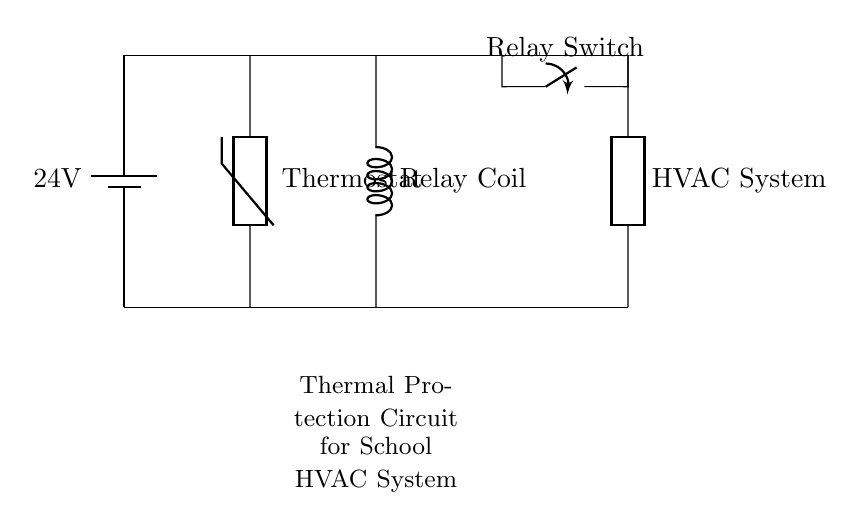What is the voltage of the power supply? The circuit indicates a voltage supply of 24 volts, as marked on the battery symbol.
Answer: 24 volts What type of component is labeled as "Thermostat"? The diagram shows a thermistor symbol, which serves as a temperature-sensing device in the circuit.
Answer: Thermistor What is the main function of the relay switch? The relay switch acts as a control device that opens or closes the circuit based on the signal from the thermostat, allowing or interrupting the operation of the HVAC system.
Answer: Control device How many components are shown in the circuit diagram? There are four main components: a battery, a thermostat, a relay coil, and a relay switch, along with the HVAC system as a generic load.
Answer: Four Why is thermal protection important for the HVAC system in a school? Thermal protection prevents overheating and ensures the HVAC system operates safely, protecting both the equipment and the building's environment, especially in a school setting where safety is paramount.
Answer: Prevent overheating What would happen if the relay coil is activated? When the relay coil is activated, it will close the relay switch, allowing power to flow to the HVAC system, thereby turning it on and providing heating or cooling as needed.
Answer: HVAC system turns on What is the role of the battery in this circuit? The battery functions as the power source, providing the necessary energy (24 volts) for the thermostat, relay coil, and ultimately the HVAC system to operate.
Answer: Power source 